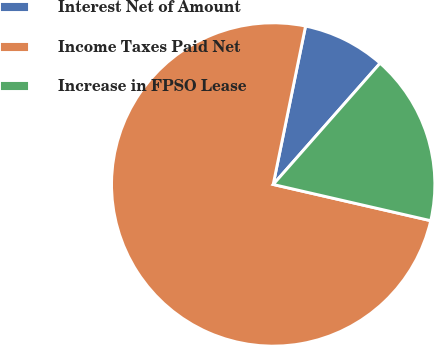Convert chart. <chart><loc_0><loc_0><loc_500><loc_500><pie_chart><fcel>Interest Net of Amount<fcel>Income Taxes Paid Net<fcel>Increase in FPSO Lease<nl><fcel>8.29%<fcel>74.61%<fcel>17.1%<nl></chart> 